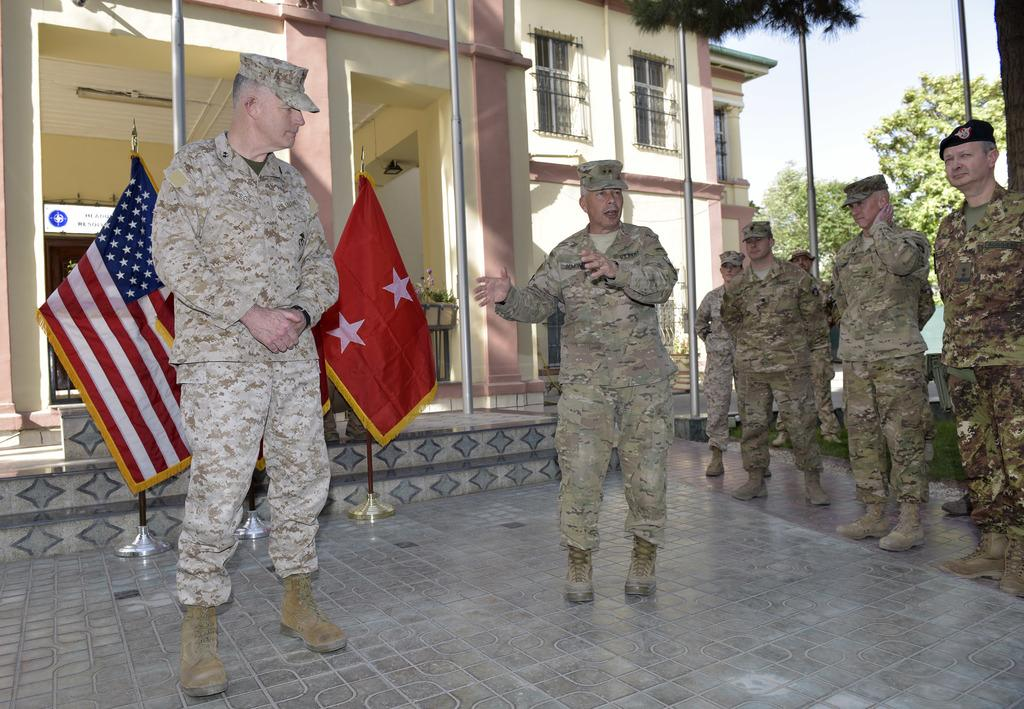How many people are in the image? There are many persons in the image. What are the persons wearing? The persons are wearing army dresses. What is at the bottom of the image? There is a floor at the bottom of the image. What can be seen in the background of the image? There are flags and a building in the background of the image. What type of vegetation is visible to the right of the image? There are trees to the right of the image. What are the names of the pigs in the image? There are no pigs present in the image. What does the image need to be complete? The image is already complete as it is; no additional elements are needed. 